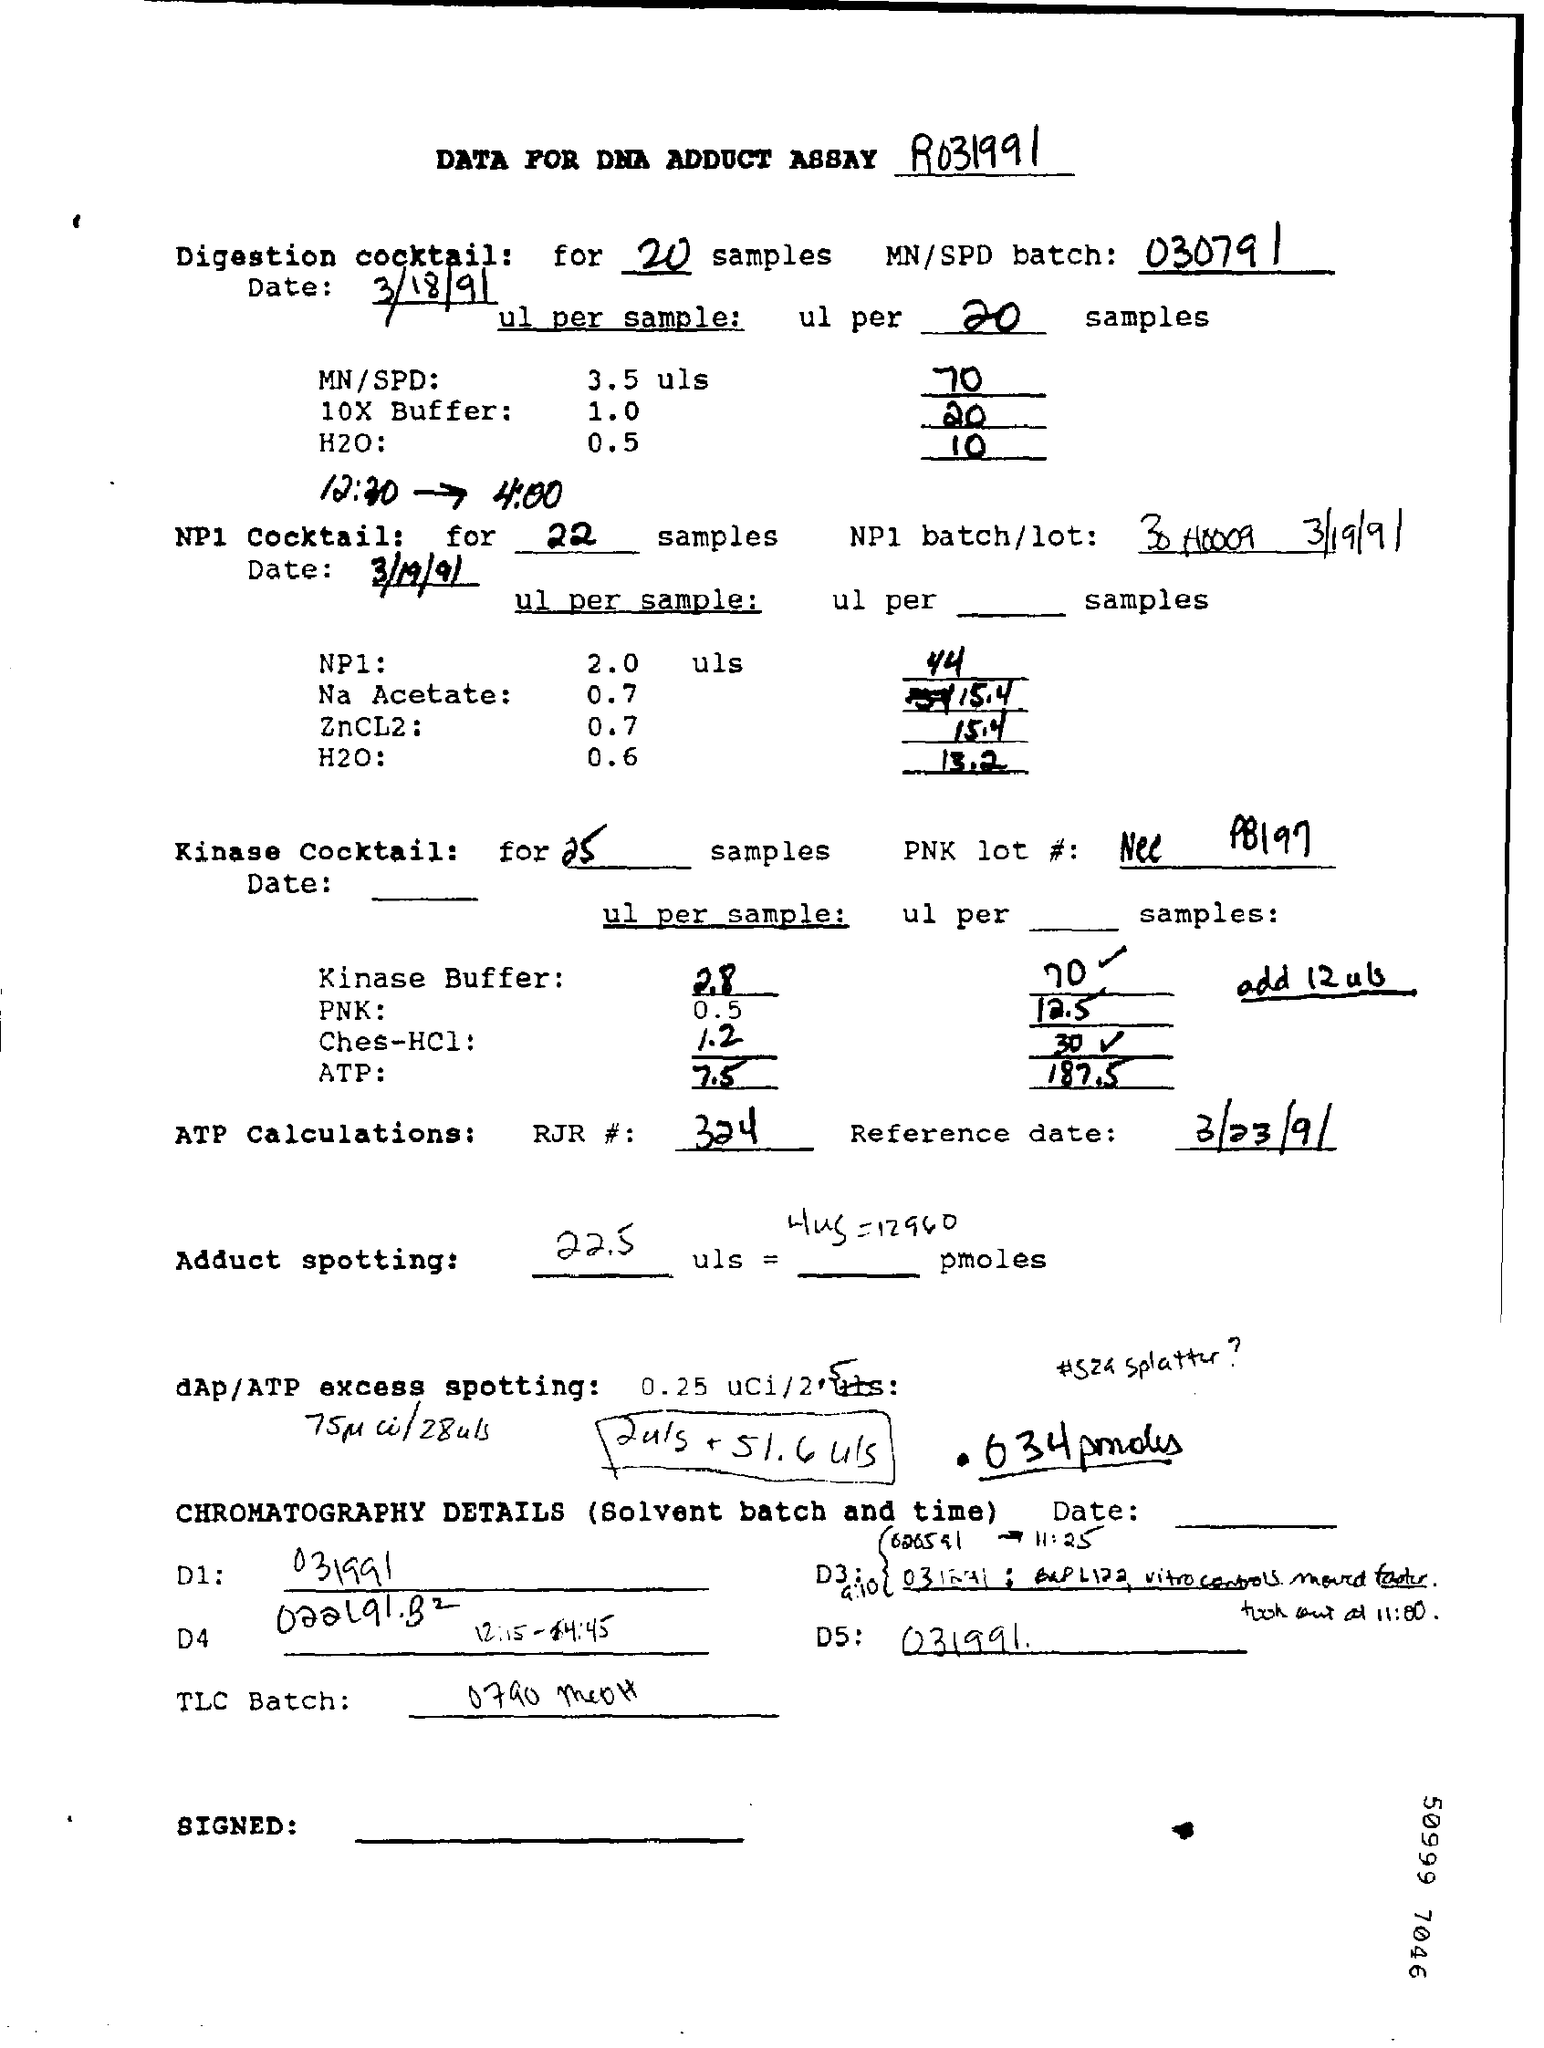Give some essential details in this illustration. The date of testing for the digestion cocktail is March 18th, 1991. The optimal number of samples for a digestion cocktail is 20. 